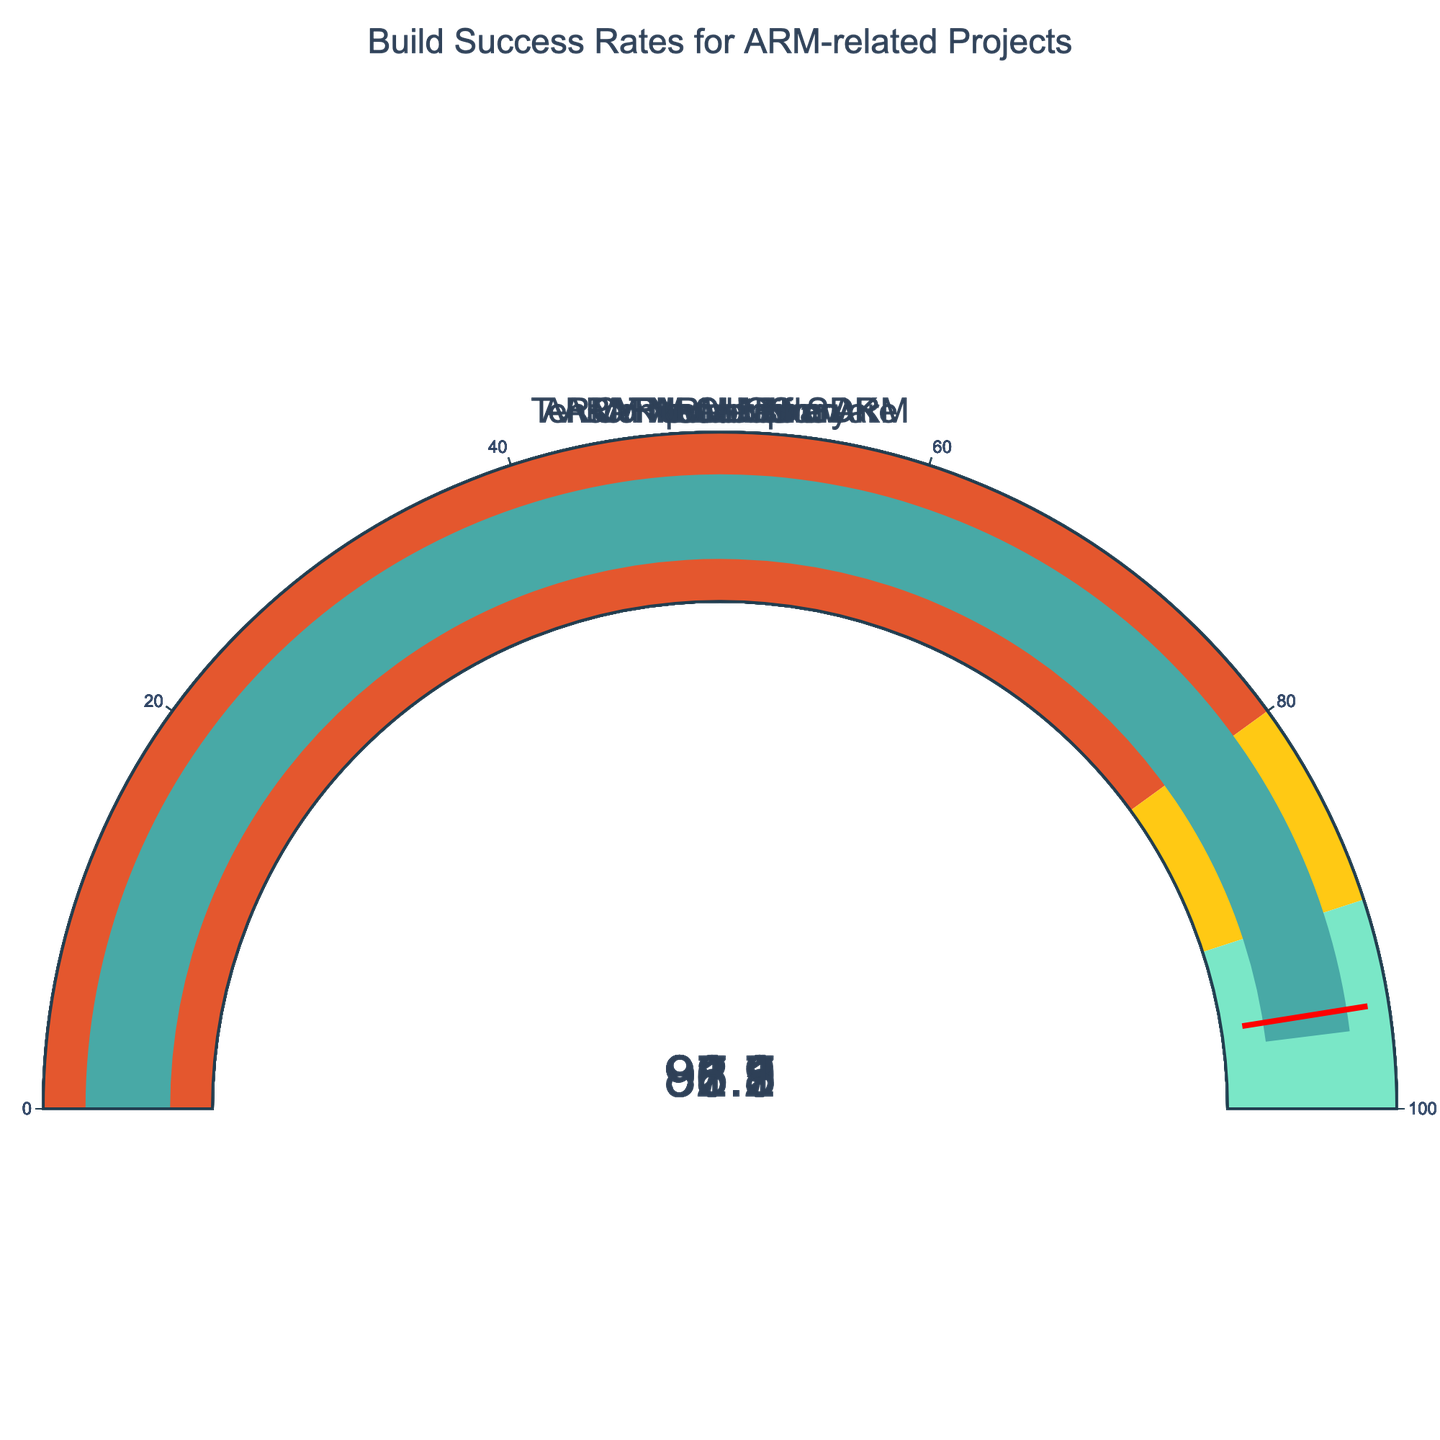What is the title of the figure? The title of the figure is located at the top center of the chart. It provides an overview of what the chart represents.
Answer: Build Success Rates for ARM-related Projects Which project has the highest build success rate? Locate the gauge with the highest value, which indicates the project's build success rate.
Answer: ARM Trusted Firmware What is the build success rate of TensorFlow Lite for ARM? Identify the gauge corresponding to TensorFlow Lite for ARM and read the value displayed.
Answer: 87.9% How many projects have a build success rate of over 90%? Count the number of gauges with values greater than 90%.
Answer: 5 Which project has the lowest build success rate? Locate the gauge with the lowest value, which indicates the project's build success rate.
Answer: TensorFlow Lite for ARM What is the difference in build success rate between Compute Library and ARM Compiler? Subtract the build success rate of ARM Compiler from Compute Library.
Answer: 1.3% What is the average build success rate of all the projects? Add the build success rates of all projects and divide by the number of projects. (92.5 + 88.7 + 95.3 + 91.2 + 87.9 + 93.8 + 96.1) / 7 = 92.21
Answer: 92.21% What is the range of the build success rates shown in the chart? Subtract the lowest build success rate from the highest build success rate. (96.1 - 87.9)
Answer: 8.2% How many projects fall within the 80% to 90% success rate range? Count the number of gauges that have values between 80 and 90%.
Answer: 2 Which two projects have the closest build success rates? Compare the numerical values of the build success rates and identify the minimal difference. Compute Library (92.5%) and ARM Compiler (91.2%) have the smallest difference of 1.3.
Answer: Compute Library and ARM Compiler 